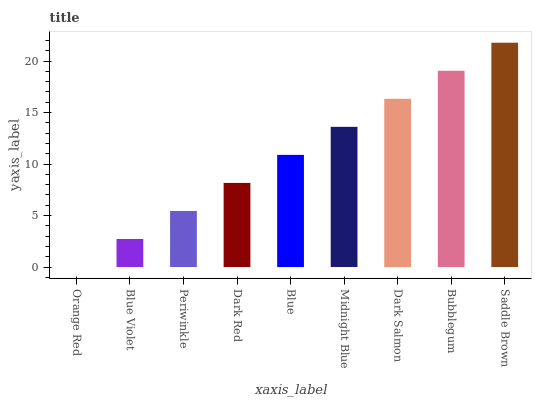Is Blue Violet the minimum?
Answer yes or no. No. Is Blue Violet the maximum?
Answer yes or no. No. Is Blue Violet greater than Orange Red?
Answer yes or no. Yes. Is Orange Red less than Blue Violet?
Answer yes or no. Yes. Is Orange Red greater than Blue Violet?
Answer yes or no. No. Is Blue Violet less than Orange Red?
Answer yes or no. No. Is Blue the high median?
Answer yes or no. Yes. Is Blue the low median?
Answer yes or no. Yes. Is Midnight Blue the high median?
Answer yes or no. No. Is Dark Red the low median?
Answer yes or no. No. 